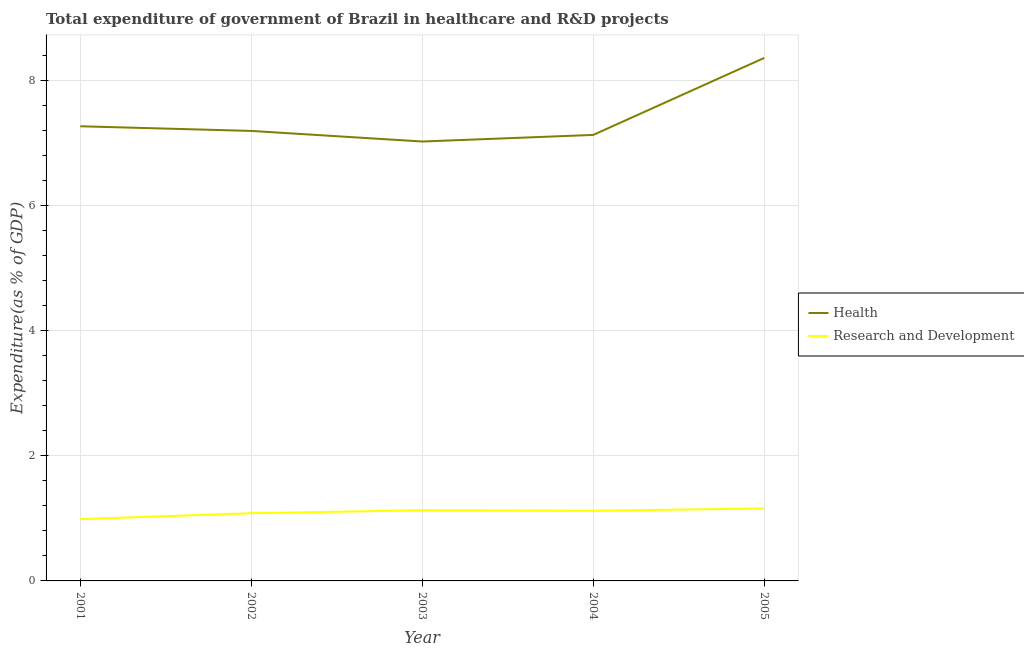How many different coloured lines are there?
Offer a terse response. 2. Does the line corresponding to expenditure in healthcare intersect with the line corresponding to expenditure in r&d?
Offer a very short reply. No. What is the expenditure in healthcare in 2002?
Offer a terse response. 7.19. Across all years, what is the maximum expenditure in r&d?
Offer a very short reply. 1.16. Across all years, what is the minimum expenditure in r&d?
Keep it short and to the point. 0.99. In which year was the expenditure in healthcare maximum?
Provide a short and direct response. 2005. In which year was the expenditure in healthcare minimum?
Provide a succinct answer. 2003. What is the total expenditure in r&d in the graph?
Your response must be concise. 5.48. What is the difference between the expenditure in healthcare in 2003 and that in 2005?
Make the answer very short. -1.34. What is the difference between the expenditure in healthcare in 2005 and the expenditure in r&d in 2002?
Your answer should be very brief. 7.28. What is the average expenditure in healthcare per year?
Your response must be concise. 7.4. In the year 2004, what is the difference between the expenditure in r&d and expenditure in healthcare?
Keep it short and to the point. -6.01. In how many years, is the expenditure in healthcare greater than 7.2 %?
Offer a very short reply. 2. What is the ratio of the expenditure in r&d in 2001 to that in 2004?
Make the answer very short. 0.88. Is the expenditure in r&d in 2002 less than that in 2005?
Your answer should be compact. Yes. Is the difference between the expenditure in healthcare in 2001 and 2003 greater than the difference between the expenditure in r&d in 2001 and 2003?
Provide a short and direct response. Yes. What is the difference between the highest and the second highest expenditure in healthcare?
Your answer should be compact. 1.09. What is the difference between the highest and the lowest expenditure in r&d?
Offer a very short reply. 0.17. In how many years, is the expenditure in healthcare greater than the average expenditure in healthcare taken over all years?
Provide a short and direct response. 1. Does the expenditure in r&d monotonically increase over the years?
Give a very brief answer. No. Is the expenditure in r&d strictly less than the expenditure in healthcare over the years?
Make the answer very short. Yes. How many years are there in the graph?
Offer a very short reply. 5. What is the difference between two consecutive major ticks on the Y-axis?
Keep it short and to the point. 2. How many legend labels are there?
Give a very brief answer. 2. How are the legend labels stacked?
Give a very brief answer. Vertical. What is the title of the graph?
Offer a very short reply. Total expenditure of government of Brazil in healthcare and R&D projects. What is the label or title of the X-axis?
Your answer should be very brief. Year. What is the label or title of the Y-axis?
Provide a short and direct response. Expenditure(as % of GDP). What is the Expenditure(as % of GDP) of Health in 2001?
Your answer should be compact. 7.27. What is the Expenditure(as % of GDP) of Research and Development in 2001?
Your answer should be very brief. 0.99. What is the Expenditure(as % of GDP) of Health in 2002?
Your response must be concise. 7.19. What is the Expenditure(as % of GDP) of Research and Development in 2002?
Provide a succinct answer. 1.08. What is the Expenditure(as % of GDP) in Health in 2003?
Offer a very short reply. 7.03. What is the Expenditure(as % of GDP) in Research and Development in 2003?
Offer a very short reply. 1.13. What is the Expenditure(as % of GDP) of Health in 2004?
Your answer should be very brief. 7.13. What is the Expenditure(as % of GDP) in Research and Development in 2004?
Provide a succinct answer. 1.12. What is the Expenditure(as % of GDP) in Health in 2005?
Offer a very short reply. 8.36. What is the Expenditure(as % of GDP) in Research and Development in 2005?
Provide a succinct answer. 1.16. Across all years, what is the maximum Expenditure(as % of GDP) of Health?
Give a very brief answer. 8.36. Across all years, what is the maximum Expenditure(as % of GDP) in Research and Development?
Ensure brevity in your answer.  1.16. Across all years, what is the minimum Expenditure(as % of GDP) in Health?
Make the answer very short. 7.03. Across all years, what is the minimum Expenditure(as % of GDP) of Research and Development?
Offer a terse response. 0.99. What is the total Expenditure(as % of GDP) in Health in the graph?
Provide a short and direct response. 36.98. What is the total Expenditure(as % of GDP) of Research and Development in the graph?
Make the answer very short. 5.48. What is the difference between the Expenditure(as % of GDP) of Health in 2001 and that in 2002?
Provide a short and direct response. 0.07. What is the difference between the Expenditure(as % of GDP) of Research and Development in 2001 and that in 2002?
Your response must be concise. -0.09. What is the difference between the Expenditure(as % of GDP) of Health in 2001 and that in 2003?
Ensure brevity in your answer.  0.24. What is the difference between the Expenditure(as % of GDP) of Research and Development in 2001 and that in 2003?
Your answer should be very brief. -0.14. What is the difference between the Expenditure(as % of GDP) of Health in 2001 and that in 2004?
Provide a succinct answer. 0.14. What is the difference between the Expenditure(as % of GDP) in Research and Development in 2001 and that in 2004?
Make the answer very short. -0.13. What is the difference between the Expenditure(as % of GDP) of Health in 2001 and that in 2005?
Keep it short and to the point. -1.09. What is the difference between the Expenditure(as % of GDP) in Research and Development in 2001 and that in 2005?
Make the answer very short. -0.17. What is the difference between the Expenditure(as % of GDP) of Health in 2002 and that in 2003?
Your answer should be compact. 0.17. What is the difference between the Expenditure(as % of GDP) in Research and Development in 2002 and that in 2003?
Give a very brief answer. -0.05. What is the difference between the Expenditure(as % of GDP) of Health in 2002 and that in 2004?
Your response must be concise. 0.06. What is the difference between the Expenditure(as % of GDP) in Research and Development in 2002 and that in 2004?
Your response must be concise. -0.04. What is the difference between the Expenditure(as % of GDP) of Health in 2002 and that in 2005?
Give a very brief answer. -1.17. What is the difference between the Expenditure(as % of GDP) of Research and Development in 2002 and that in 2005?
Give a very brief answer. -0.08. What is the difference between the Expenditure(as % of GDP) in Health in 2003 and that in 2004?
Your response must be concise. -0.11. What is the difference between the Expenditure(as % of GDP) of Research and Development in 2003 and that in 2004?
Ensure brevity in your answer.  0.01. What is the difference between the Expenditure(as % of GDP) of Health in 2003 and that in 2005?
Offer a very short reply. -1.34. What is the difference between the Expenditure(as % of GDP) of Research and Development in 2003 and that in 2005?
Your response must be concise. -0.03. What is the difference between the Expenditure(as % of GDP) of Health in 2004 and that in 2005?
Your response must be concise. -1.23. What is the difference between the Expenditure(as % of GDP) in Research and Development in 2004 and that in 2005?
Provide a short and direct response. -0.04. What is the difference between the Expenditure(as % of GDP) of Health in 2001 and the Expenditure(as % of GDP) of Research and Development in 2002?
Keep it short and to the point. 6.19. What is the difference between the Expenditure(as % of GDP) in Health in 2001 and the Expenditure(as % of GDP) in Research and Development in 2003?
Keep it short and to the point. 6.14. What is the difference between the Expenditure(as % of GDP) in Health in 2001 and the Expenditure(as % of GDP) in Research and Development in 2004?
Your answer should be compact. 6.15. What is the difference between the Expenditure(as % of GDP) of Health in 2001 and the Expenditure(as % of GDP) of Research and Development in 2005?
Provide a succinct answer. 6.11. What is the difference between the Expenditure(as % of GDP) of Health in 2002 and the Expenditure(as % of GDP) of Research and Development in 2003?
Keep it short and to the point. 6.06. What is the difference between the Expenditure(as % of GDP) in Health in 2002 and the Expenditure(as % of GDP) in Research and Development in 2004?
Offer a very short reply. 6.07. What is the difference between the Expenditure(as % of GDP) of Health in 2002 and the Expenditure(as % of GDP) of Research and Development in 2005?
Offer a terse response. 6.03. What is the difference between the Expenditure(as % of GDP) in Health in 2003 and the Expenditure(as % of GDP) in Research and Development in 2004?
Offer a very short reply. 5.9. What is the difference between the Expenditure(as % of GDP) of Health in 2003 and the Expenditure(as % of GDP) of Research and Development in 2005?
Make the answer very short. 5.87. What is the difference between the Expenditure(as % of GDP) in Health in 2004 and the Expenditure(as % of GDP) in Research and Development in 2005?
Make the answer very short. 5.97. What is the average Expenditure(as % of GDP) of Health per year?
Your answer should be compact. 7.4. What is the average Expenditure(as % of GDP) in Research and Development per year?
Make the answer very short. 1.1. In the year 2001, what is the difference between the Expenditure(as % of GDP) of Health and Expenditure(as % of GDP) of Research and Development?
Offer a terse response. 6.28. In the year 2002, what is the difference between the Expenditure(as % of GDP) of Health and Expenditure(as % of GDP) of Research and Development?
Your response must be concise. 6.11. In the year 2003, what is the difference between the Expenditure(as % of GDP) in Health and Expenditure(as % of GDP) in Research and Development?
Ensure brevity in your answer.  5.9. In the year 2004, what is the difference between the Expenditure(as % of GDP) in Health and Expenditure(as % of GDP) in Research and Development?
Your answer should be very brief. 6.01. In the year 2005, what is the difference between the Expenditure(as % of GDP) of Health and Expenditure(as % of GDP) of Research and Development?
Your response must be concise. 7.2. What is the ratio of the Expenditure(as % of GDP) in Health in 2001 to that in 2002?
Give a very brief answer. 1.01. What is the ratio of the Expenditure(as % of GDP) in Research and Development in 2001 to that in 2002?
Your answer should be very brief. 0.91. What is the ratio of the Expenditure(as % of GDP) in Health in 2001 to that in 2003?
Your response must be concise. 1.03. What is the ratio of the Expenditure(as % of GDP) of Research and Development in 2001 to that in 2003?
Your answer should be very brief. 0.87. What is the ratio of the Expenditure(as % of GDP) in Health in 2001 to that in 2004?
Your answer should be compact. 1.02. What is the ratio of the Expenditure(as % of GDP) of Research and Development in 2001 to that in 2004?
Provide a short and direct response. 0.88. What is the ratio of the Expenditure(as % of GDP) in Health in 2001 to that in 2005?
Offer a terse response. 0.87. What is the ratio of the Expenditure(as % of GDP) of Research and Development in 2001 to that in 2005?
Provide a succinct answer. 0.85. What is the ratio of the Expenditure(as % of GDP) of Health in 2002 to that in 2003?
Make the answer very short. 1.02. What is the ratio of the Expenditure(as % of GDP) in Research and Development in 2002 to that in 2003?
Provide a short and direct response. 0.96. What is the ratio of the Expenditure(as % of GDP) in Research and Development in 2002 to that in 2004?
Provide a succinct answer. 0.97. What is the ratio of the Expenditure(as % of GDP) of Health in 2002 to that in 2005?
Give a very brief answer. 0.86. What is the ratio of the Expenditure(as % of GDP) of Health in 2003 to that in 2004?
Make the answer very short. 0.99. What is the ratio of the Expenditure(as % of GDP) in Research and Development in 2003 to that in 2004?
Provide a short and direct response. 1.01. What is the ratio of the Expenditure(as % of GDP) of Health in 2003 to that in 2005?
Provide a succinct answer. 0.84. What is the ratio of the Expenditure(as % of GDP) of Research and Development in 2003 to that in 2005?
Provide a short and direct response. 0.97. What is the ratio of the Expenditure(as % of GDP) in Health in 2004 to that in 2005?
Offer a terse response. 0.85. What is the ratio of the Expenditure(as % of GDP) of Research and Development in 2004 to that in 2005?
Ensure brevity in your answer.  0.97. What is the difference between the highest and the second highest Expenditure(as % of GDP) of Health?
Offer a terse response. 1.09. What is the difference between the highest and the second highest Expenditure(as % of GDP) of Research and Development?
Offer a very short reply. 0.03. What is the difference between the highest and the lowest Expenditure(as % of GDP) of Health?
Your answer should be compact. 1.34. What is the difference between the highest and the lowest Expenditure(as % of GDP) in Research and Development?
Keep it short and to the point. 0.17. 